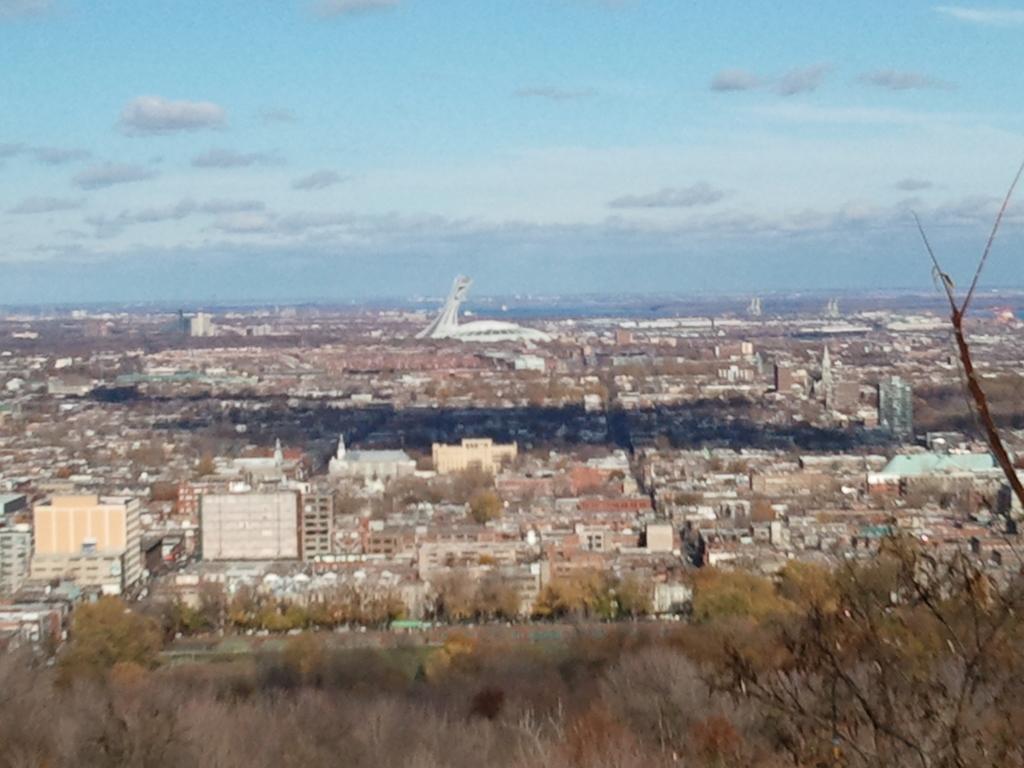In one or two sentences, can you explain what this image depicts? In this picture we can observe city. There are buildings and houses. We can observe some trees and grass on the ground. In the background there is a sky with some clouds. 